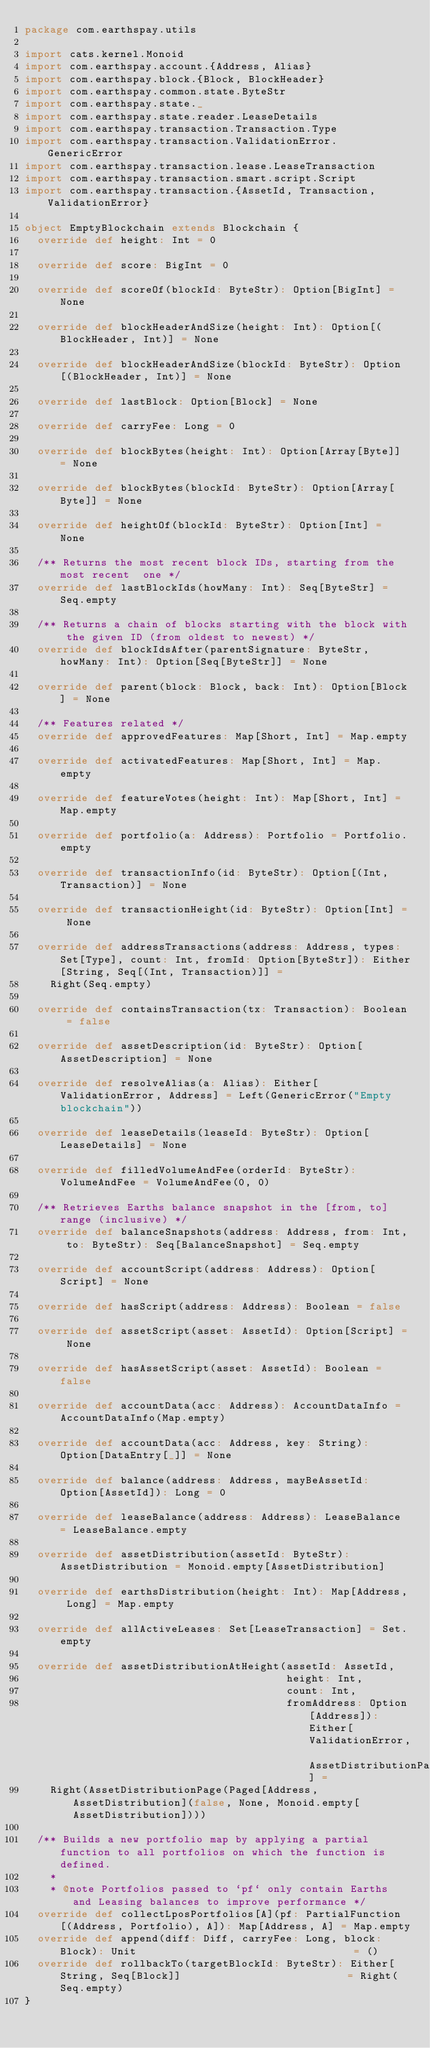Convert code to text. <code><loc_0><loc_0><loc_500><loc_500><_Scala_>package com.earthspay.utils

import cats.kernel.Monoid
import com.earthspay.account.{Address, Alias}
import com.earthspay.block.{Block, BlockHeader}
import com.earthspay.common.state.ByteStr
import com.earthspay.state._
import com.earthspay.state.reader.LeaseDetails
import com.earthspay.transaction.Transaction.Type
import com.earthspay.transaction.ValidationError.GenericError
import com.earthspay.transaction.lease.LeaseTransaction
import com.earthspay.transaction.smart.script.Script
import com.earthspay.transaction.{AssetId, Transaction, ValidationError}

object EmptyBlockchain extends Blockchain {
  override def height: Int = 0

  override def score: BigInt = 0

  override def scoreOf(blockId: ByteStr): Option[BigInt] = None

  override def blockHeaderAndSize(height: Int): Option[(BlockHeader, Int)] = None

  override def blockHeaderAndSize(blockId: ByteStr): Option[(BlockHeader, Int)] = None

  override def lastBlock: Option[Block] = None

  override def carryFee: Long = 0

  override def blockBytes(height: Int): Option[Array[Byte]] = None

  override def blockBytes(blockId: ByteStr): Option[Array[Byte]] = None

  override def heightOf(blockId: ByteStr): Option[Int] = None

  /** Returns the most recent block IDs, starting from the most recent  one */
  override def lastBlockIds(howMany: Int): Seq[ByteStr] = Seq.empty

  /** Returns a chain of blocks starting with the block with the given ID (from oldest to newest) */
  override def blockIdsAfter(parentSignature: ByteStr, howMany: Int): Option[Seq[ByteStr]] = None

  override def parent(block: Block, back: Int): Option[Block] = None

  /** Features related */
  override def approvedFeatures: Map[Short, Int] = Map.empty

  override def activatedFeatures: Map[Short, Int] = Map.empty

  override def featureVotes(height: Int): Map[Short, Int] = Map.empty

  override def portfolio(a: Address): Portfolio = Portfolio.empty

  override def transactionInfo(id: ByteStr): Option[(Int, Transaction)] = None

  override def transactionHeight(id: ByteStr): Option[Int] = None

  override def addressTransactions(address: Address, types: Set[Type], count: Int, fromId: Option[ByteStr]): Either[String, Seq[(Int, Transaction)]] =
    Right(Seq.empty)

  override def containsTransaction(tx: Transaction): Boolean = false

  override def assetDescription(id: ByteStr): Option[AssetDescription] = None

  override def resolveAlias(a: Alias): Either[ValidationError, Address] = Left(GenericError("Empty blockchain"))

  override def leaseDetails(leaseId: ByteStr): Option[LeaseDetails] = None

  override def filledVolumeAndFee(orderId: ByteStr): VolumeAndFee = VolumeAndFee(0, 0)

  /** Retrieves Earths balance snapshot in the [from, to] range (inclusive) */
  override def balanceSnapshots(address: Address, from: Int, to: ByteStr): Seq[BalanceSnapshot] = Seq.empty

  override def accountScript(address: Address): Option[Script] = None

  override def hasScript(address: Address): Boolean = false

  override def assetScript(asset: AssetId): Option[Script] = None

  override def hasAssetScript(asset: AssetId): Boolean = false

  override def accountData(acc: Address): AccountDataInfo = AccountDataInfo(Map.empty)

  override def accountData(acc: Address, key: String): Option[DataEntry[_]] = None

  override def balance(address: Address, mayBeAssetId: Option[AssetId]): Long = 0

  override def leaseBalance(address: Address): LeaseBalance = LeaseBalance.empty

  override def assetDistribution(assetId: ByteStr): AssetDistribution = Monoid.empty[AssetDistribution]

  override def earthsDistribution(height: Int): Map[Address, Long] = Map.empty

  override def allActiveLeases: Set[LeaseTransaction] = Set.empty

  override def assetDistributionAtHeight(assetId: AssetId,
                                         height: Int,
                                         count: Int,
                                         fromAddress: Option[Address]): Either[ValidationError, AssetDistributionPage] =
    Right(AssetDistributionPage(Paged[Address, AssetDistribution](false, None, Monoid.empty[AssetDistribution])))

  /** Builds a new portfolio map by applying a partial function to all portfolios on which the function is defined.
    *
    * @note Portfolios passed to `pf` only contain Earths and Leasing balances to improve performance */
  override def collectLposPortfolios[A](pf: PartialFunction[(Address, Portfolio), A]): Map[Address, A] = Map.empty
  override def append(diff: Diff, carryFee: Long, block: Block): Unit                                  = ()
  override def rollbackTo(targetBlockId: ByteStr): Either[String, Seq[Block]]                          = Right(Seq.empty)
}
</code> 